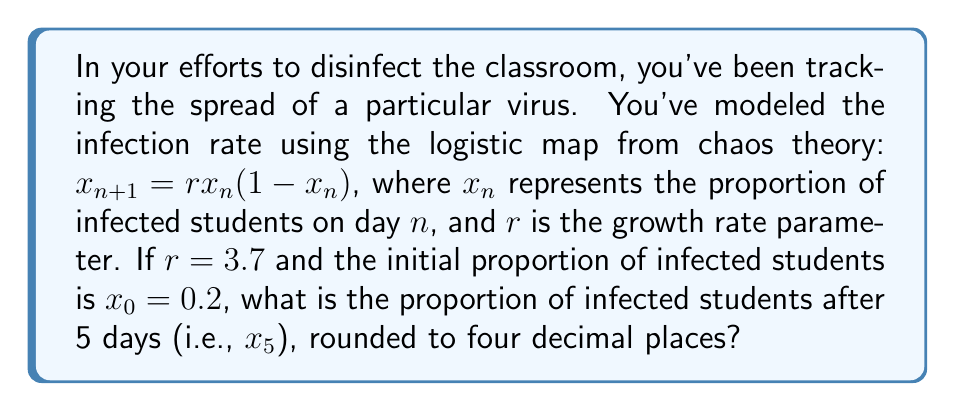Could you help me with this problem? To solve this problem, we need to iterate the logistic map equation five times:

1) For $n = 0$:
   $x_1 = 3.7 \cdot 0.2 \cdot (1-0.2) = 3.7 \cdot 0.2 \cdot 0.8 = 0.592$

2) For $n = 1$:
   $x_2 = 3.7 \cdot 0.592 \cdot (1-0.592) = 3.7 \cdot 0.592 \cdot 0.408 = 0.8934$

3) For $n = 2$:
   $x_3 = 3.7 \cdot 0.8934 \cdot (1-0.8934) = 3.7 \cdot 0.8934 \cdot 0.1066 = 0.3532$

4) For $n = 3$:
   $x_4 = 3.7 \cdot 0.3532 \cdot (1-0.3532) = 3.7 \cdot 0.3532 \cdot 0.6468 = 0.8439$

5) For $n = 4$:
   $x_5 = 3.7 \cdot 0.8439 \cdot (1-0.8439) = 3.7 \cdot 0.8439 \cdot 0.1561 = 0.4879$

Rounding to four decimal places, we get 0.4879.
Answer: 0.4879 